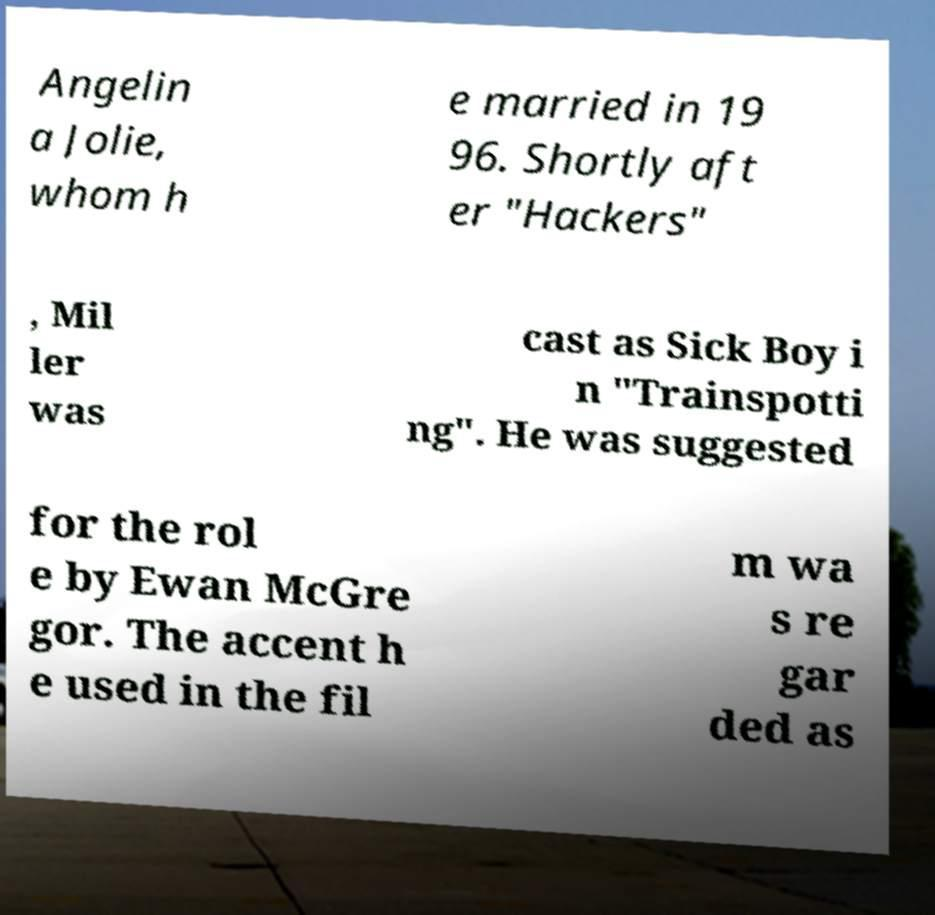What messages or text are displayed in this image? I need them in a readable, typed format. Angelin a Jolie, whom h e married in 19 96. Shortly aft er "Hackers" , Mil ler was cast as Sick Boy i n "Trainspotti ng". He was suggested for the rol e by Ewan McGre gor. The accent h e used in the fil m wa s re gar ded as 